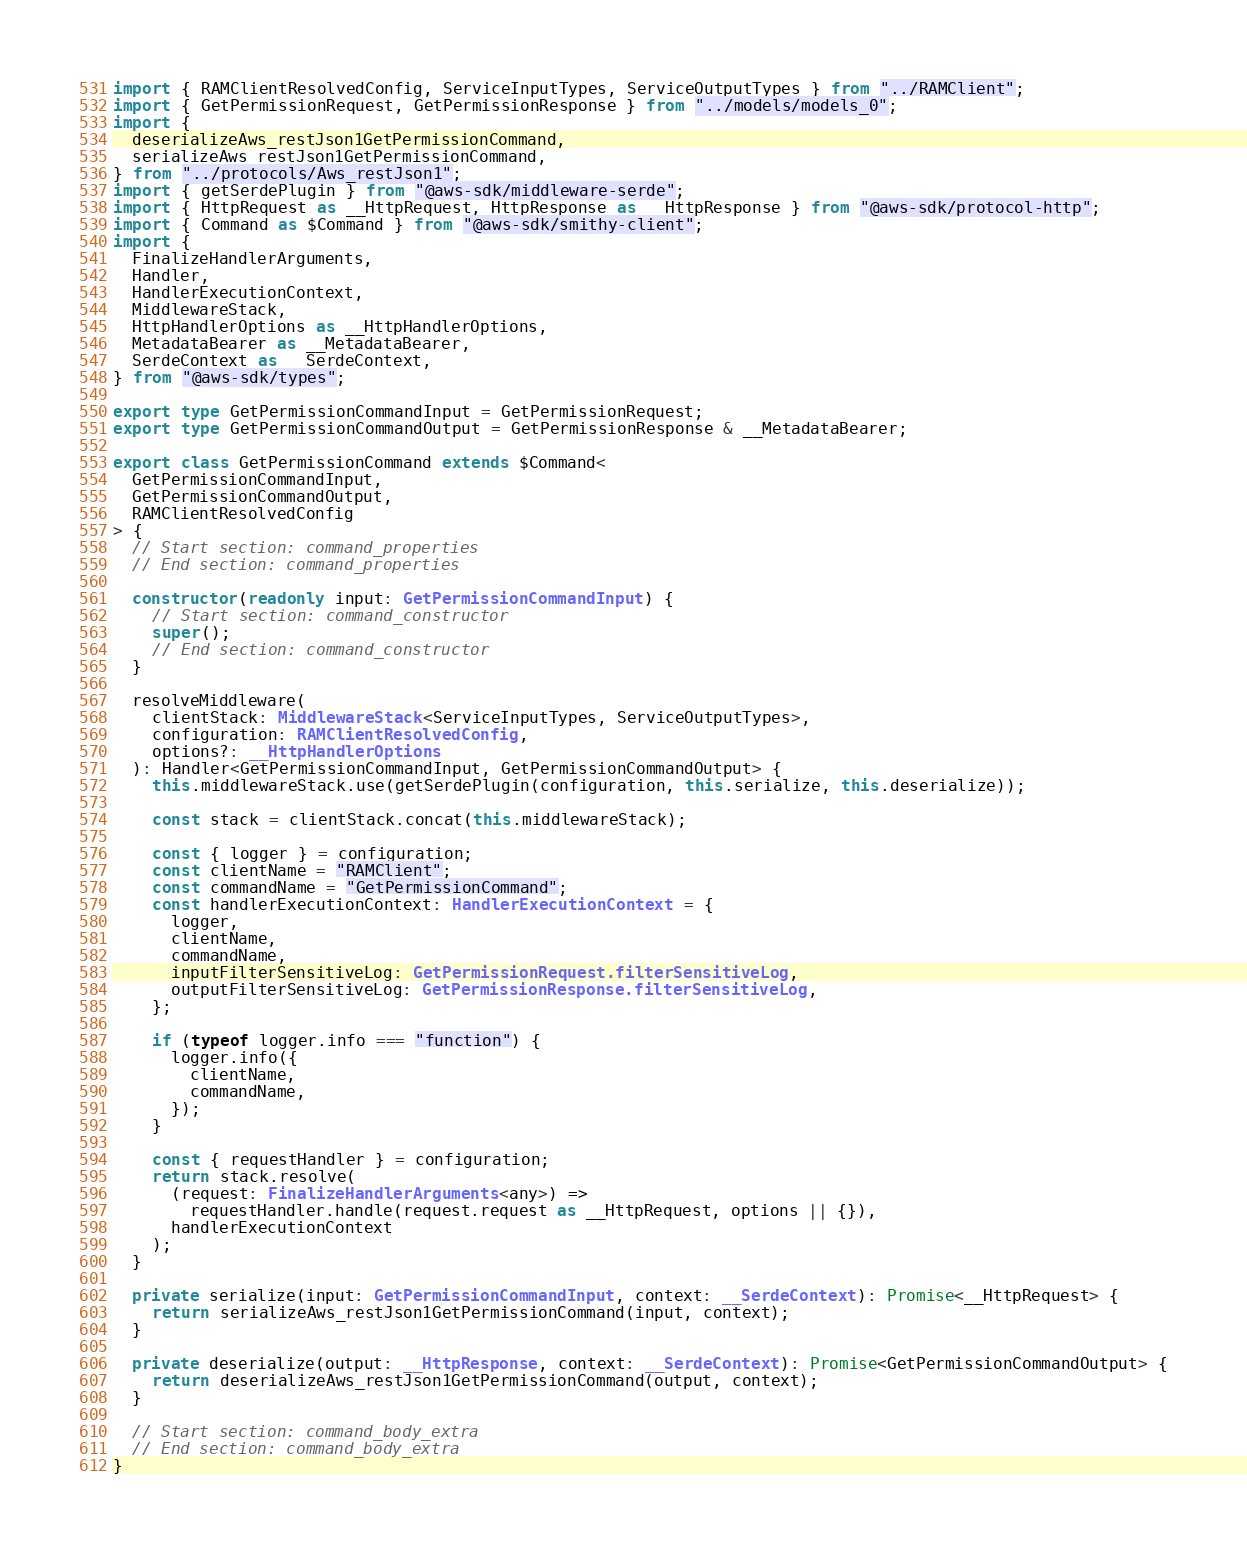Convert code to text. <code><loc_0><loc_0><loc_500><loc_500><_TypeScript_>import { RAMClientResolvedConfig, ServiceInputTypes, ServiceOutputTypes } from "../RAMClient";
import { GetPermissionRequest, GetPermissionResponse } from "../models/models_0";
import {
  deserializeAws_restJson1GetPermissionCommand,
  serializeAws_restJson1GetPermissionCommand,
} from "../protocols/Aws_restJson1";
import { getSerdePlugin } from "@aws-sdk/middleware-serde";
import { HttpRequest as __HttpRequest, HttpResponse as __HttpResponse } from "@aws-sdk/protocol-http";
import { Command as $Command } from "@aws-sdk/smithy-client";
import {
  FinalizeHandlerArguments,
  Handler,
  HandlerExecutionContext,
  MiddlewareStack,
  HttpHandlerOptions as __HttpHandlerOptions,
  MetadataBearer as __MetadataBearer,
  SerdeContext as __SerdeContext,
} from "@aws-sdk/types";

export type GetPermissionCommandInput = GetPermissionRequest;
export type GetPermissionCommandOutput = GetPermissionResponse & __MetadataBearer;

export class GetPermissionCommand extends $Command<
  GetPermissionCommandInput,
  GetPermissionCommandOutput,
  RAMClientResolvedConfig
> {
  // Start section: command_properties
  // End section: command_properties

  constructor(readonly input: GetPermissionCommandInput) {
    // Start section: command_constructor
    super();
    // End section: command_constructor
  }

  resolveMiddleware(
    clientStack: MiddlewareStack<ServiceInputTypes, ServiceOutputTypes>,
    configuration: RAMClientResolvedConfig,
    options?: __HttpHandlerOptions
  ): Handler<GetPermissionCommandInput, GetPermissionCommandOutput> {
    this.middlewareStack.use(getSerdePlugin(configuration, this.serialize, this.deserialize));

    const stack = clientStack.concat(this.middlewareStack);

    const { logger } = configuration;
    const clientName = "RAMClient";
    const commandName = "GetPermissionCommand";
    const handlerExecutionContext: HandlerExecutionContext = {
      logger,
      clientName,
      commandName,
      inputFilterSensitiveLog: GetPermissionRequest.filterSensitiveLog,
      outputFilterSensitiveLog: GetPermissionResponse.filterSensitiveLog,
    };

    if (typeof logger.info === "function") {
      logger.info({
        clientName,
        commandName,
      });
    }

    const { requestHandler } = configuration;
    return stack.resolve(
      (request: FinalizeHandlerArguments<any>) =>
        requestHandler.handle(request.request as __HttpRequest, options || {}),
      handlerExecutionContext
    );
  }

  private serialize(input: GetPermissionCommandInput, context: __SerdeContext): Promise<__HttpRequest> {
    return serializeAws_restJson1GetPermissionCommand(input, context);
  }

  private deserialize(output: __HttpResponse, context: __SerdeContext): Promise<GetPermissionCommandOutput> {
    return deserializeAws_restJson1GetPermissionCommand(output, context);
  }

  // Start section: command_body_extra
  // End section: command_body_extra
}
</code> 